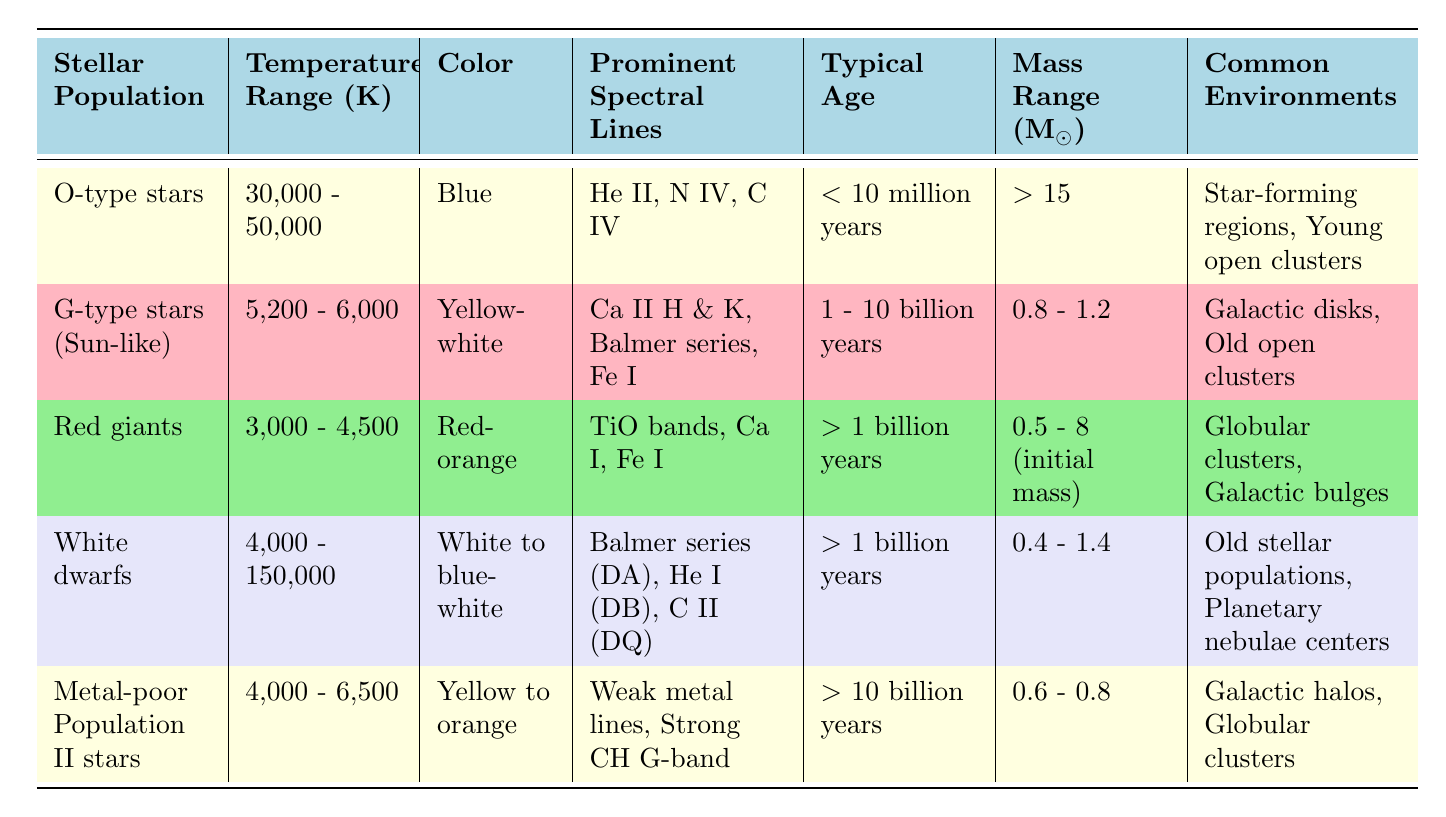What is the typical age range for O-type stars? The table lists the typical age for O-type stars as less than 10 million years, which is a direct reference from the data provided in that row.
Answer: Less than 10 million years Which stellar population has the widest temperature range? The temperature ranges for the populations are: O-type stars (30,000 - 50,000 K), G-type stars (5,200 - 6,000 K), Red giants (3,000 - 4,500 K), White dwarfs (4,000 - 150,000 K), and Metal-poor Population II stars (4,000 - 6,500 K). Comparing these, White dwarfs have the widest range from 4,000 K to 150,000 K.
Answer: White dwarfs Are G-type stars typically older than Metal-poor Population II stars? G-type stars have a typical age range of 1 to 10 billion years, while Metal-poor Population II stars have a typical age of greater than 10 billion years. Since 1 billion years is less than 10 billion years, the statement is false.
Answer: No What is the average mass range of the Red giants? The mass range for Red giants is listed as between 0.5 to 8 solar masses. To find the average, add the lower mass (0.5) and upper mass (8) giving 8.5, then divide by 2 for the average, which is 4.25 solar masses.
Answer: 4.25 M☉ Which stellar populations are commonly found in globular clusters? The table indicates that both Red giants and Metal-poor Population II stars are commonly found in globular clusters. Therefore, both exist in these environments according to the data.
Answer: Red giants and Metal-poor Population II stars What color are White dwarfs? According to the table, White dwarfs are described as being white to blue-white. This description directly corresponds to the color column for that stellar population.
Answer: White to blue-white How many stellar populations have a typical age greater than 1 billion years? The populations with ages specified as greater than 1 billion years include Red giants, White dwarfs, and Metal-poor Population II stars. This totals three populations.
Answer: 3 Is the temperature range for Metal-poor Population II stars lower than that of G-type stars? The temperature range for Metal-poor Population II stars is specified as 4,000 to 6,500 K, while for G-type stars, it’s 5,200 to 6,000 K. Since 4,000 K is lower than 5,200 K, yes, the temperature range for Metal-poor Population II stars is indeed lower.
Answer: Yes 